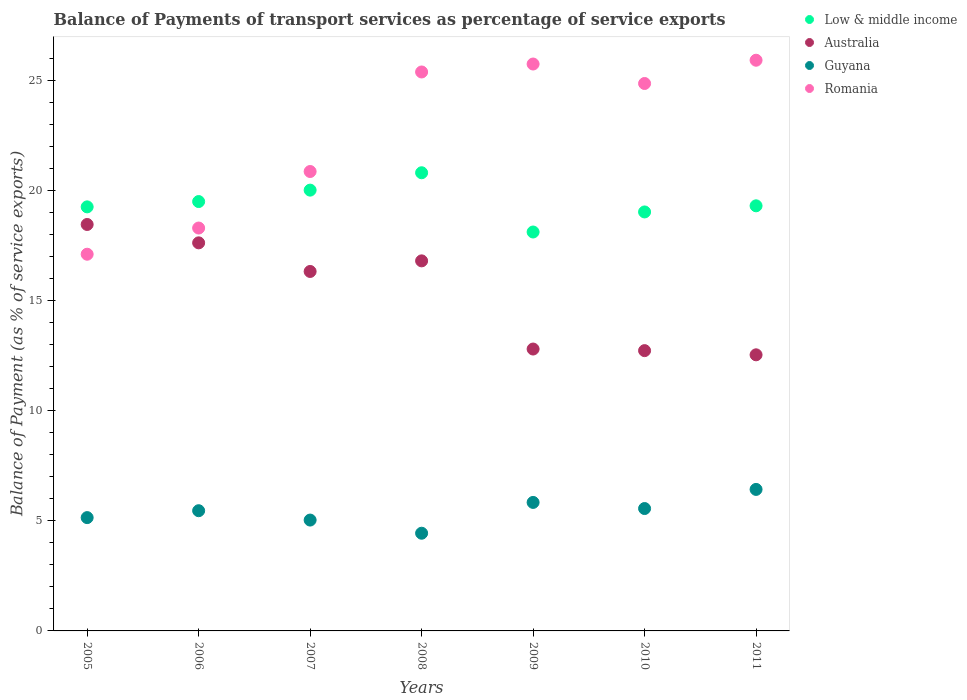How many different coloured dotlines are there?
Your answer should be very brief. 4. What is the balance of payments of transport services in Guyana in 2008?
Your response must be concise. 4.44. Across all years, what is the maximum balance of payments of transport services in Guyana?
Your response must be concise. 6.43. Across all years, what is the minimum balance of payments of transport services in Low & middle income?
Provide a short and direct response. 18.12. In which year was the balance of payments of transport services in Australia maximum?
Your answer should be very brief. 2005. In which year was the balance of payments of transport services in Romania minimum?
Provide a short and direct response. 2005. What is the total balance of payments of transport services in Romania in the graph?
Keep it short and to the point. 158.17. What is the difference between the balance of payments of transport services in Romania in 2010 and that in 2011?
Ensure brevity in your answer.  -1.06. What is the difference between the balance of payments of transport services in Romania in 2006 and the balance of payments of transport services in Low & middle income in 2005?
Provide a succinct answer. -0.96. What is the average balance of payments of transport services in Low & middle income per year?
Give a very brief answer. 19.43. In the year 2008, what is the difference between the balance of payments of transport services in Low & middle income and balance of payments of transport services in Guyana?
Provide a succinct answer. 16.37. What is the ratio of the balance of payments of transport services in Australia in 2005 to that in 2008?
Your answer should be compact. 1.1. Is the balance of payments of transport services in Low & middle income in 2008 less than that in 2011?
Provide a short and direct response. No. What is the difference between the highest and the second highest balance of payments of transport services in Australia?
Offer a very short reply. 0.83. What is the difference between the highest and the lowest balance of payments of transport services in Low & middle income?
Your answer should be very brief. 2.69. Is the sum of the balance of payments of transport services in Low & middle income in 2007 and 2011 greater than the maximum balance of payments of transport services in Romania across all years?
Your answer should be very brief. Yes. Is it the case that in every year, the sum of the balance of payments of transport services in Low & middle income and balance of payments of transport services in Guyana  is greater than the sum of balance of payments of transport services in Australia and balance of payments of transport services in Romania?
Offer a very short reply. Yes. Is it the case that in every year, the sum of the balance of payments of transport services in Australia and balance of payments of transport services in Guyana  is greater than the balance of payments of transport services in Romania?
Give a very brief answer. No. Does the balance of payments of transport services in Low & middle income monotonically increase over the years?
Provide a succinct answer. No. Is the balance of payments of transport services in Australia strictly greater than the balance of payments of transport services in Romania over the years?
Provide a succinct answer. No. How many years are there in the graph?
Provide a short and direct response. 7. What is the difference between two consecutive major ticks on the Y-axis?
Your answer should be compact. 5. Are the values on the major ticks of Y-axis written in scientific E-notation?
Give a very brief answer. No. Does the graph contain any zero values?
Offer a terse response. No. Where does the legend appear in the graph?
Ensure brevity in your answer.  Top right. How many legend labels are there?
Give a very brief answer. 4. How are the legend labels stacked?
Your answer should be compact. Vertical. What is the title of the graph?
Make the answer very short. Balance of Payments of transport services as percentage of service exports. What is the label or title of the Y-axis?
Your response must be concise. Balance of Payment (as % of service exports). What is the Balance of Payment (as % of service exports) in Low & middle income in 2005?
Give a very brief answer. 19.26. What is the Balance of Payment (as % of service exports) in Australia in 2005?
Provide a short and direct response. 18.46. What is the Balance of Payment (as % of service exports) in Guyana in 2005?
Your answer should be very brief. 5.15. What is the Balance of Payment (as % of service exports) of Romania in 2005?
Your response must be concise. 17.11. What is the Balance of Payment (as % of service exports) of Low & middle income in 2006?
Keep it short and to the point. 19.5. What is the Balance of Payment (as % of service exports) of Australia in 2006?
Ensure brevity in your answer.  17.62. What is the Balance of Payment (as % of service exports) in Guyana in 2006?
Offer a very short reply. 5.46. What is the Balance of Payment (as % of service exports) of Romania in 2006?
Give a very brief answer. 18.3. What is the Balance of Payment (as % of service exports) of Low & middle income in 2007?
Offer a very short reply. 20.02. What is the Balance of Payment (as % of service exports) in Australia in 2007?
Your answer should be compact. 16.32. What is the Balance of Payment (as % of service exports) of Guyana in 2007?
Provide a short and direct response. 5.03. What is the Balance of Payment (as % of service exports) in Romania in 2007?
Make the answer very short. 20.86. What is the Balance of Payment (as % of service exports) in Low & middle income in 2008?
Make the answer very short. 20.81. What is the Balance of Payment (as % of service exports) of Australia in 2008?
Your response must be concise. 16.81. What is the Balance of Payment (as % of service exports) in Guyana in 2008?
Provide a succinct answer. 4.44. What is the Balance of Payment (as % of service exports) in Romania in 2008?
Offer a terse response. 25.38. What is the Balance of Payment (as % of service exports) of Low & middle income in 2009?
Make the answer very short. 18.12. What is the Balance of Payment (as % of service exports) of Australia in 2009?
Ensure brevity in your answer.  12.8. What is the Balance of Payment (as % of service exports) of Guyana in 2009?
Provide a succinct answer. 5.84. What is the Balance of Payment (as % of service exports) in Romania in 2009?
Make the answer very short. 25.74. What is the Balance of Payment (as % of service exports) in Low & middle income in 2010?
Your answer should be very brief. 19.03. What is the Balance of Payment (as % of service exports) in Australia in 2010?
Your answer should be very brief. 12.73. What is the Balance of Payment (as % of service exports) in Guyana in 2010?
Offer a very short reply. 5.56. What is the Balance of Payment (as % of service exports) in Romania in 2010?
Keep it short and to the point. 24.86. What is the Balance of Payment (as % of service exports) of Low & middle income in 2011?
Offer a terse response. 19.31. What is the Balance of Payment (as % of service exports) of Australia in 2011?
Make the answer very short. 12.54. What is the Balance of Payment (as % of service exports) of Guyana in 2011?
Offer a terse response. 6.43. What is the Balance of Payment (as % of service exports) of Romania in 2011?
Make the answer very short. 25.92. Across all years, what is the maximum Balance of Payment (as % of service exports) in Low & middle income?
Provide a short and direct response. 20.81. Across all years, what is the maximum Balance of Payment (as % of service exports) in Australia?
Ensure brevity in your answer.  18.46. Across all years, what is the maximum Balance of Payment (as % of service exports) in Guyana?
Ensure brevity in your answer.  6.43. Across all years, what is the maximum Balance of Payment (as % of service exports) in Romania?
Your answer should be compact. 25.92. Across all years, what is the minimum Balance of Payment (as % of service exports) of Low & middle income?
Offer a very short reply. 18.12. Across all years, what is the minimum Balance of Payment (as % of service exports) in Australia?
Provide a short and direct response. 12.54. Across all years, what is the minimum Balance of Payment (as % of service exports) of Guyana?
Your response must be concise. 4.44. Across all years, what is the minimum Balance of Payment (as % of service exports) of Romania?
Offer a very short reply. 17.11. What is the total Balance of Payment (as % of service exports) of Low & middle income in the graph?
Offer a terse response. 136.03. What is the total Balance of Payment (as % of service exports) of Australia in the graph?
Provide a short and direct response. 107.28. What is the total Balance of Payment (as % of service exports) of Guyana in the graph?
Offer a very short reply. 37.9. What is the total Balance of Payment (as % of service exports) in Romania in the graph?
Provide a succinct answer. 158.17. What is the difference between the Balance of Payment (as % of service exports) of Low & middle income in 2005 and that in 2006?
Ensure brevity in your answer.  -0.24. What is the difference between the Balance of Payment (as % of service exports) in Australia in 2005 and that in 2006?
Keep it short and to the point. 0.83. What is the difference between the Balance of Payment (as % of service exports) in Guyana in 2005 and that in 2006?
Your answer should be compact. -0.31. What is the difference between the Balance of Payment (as % of service exports) in Romania in 2005 and that in 2006?
Ensure brevity in your answer.  -1.19. What is the difference between the Balance of Payment (as % of service exports) in Low & middle income in 2005 and that in 2007?
Offer a terse response. -0.76. What is the difference between the Balance of Payment (as % of service exports) of Australia in 2005 and that in 2007?
Offer a terse response. 2.13. What is the difference between the Balance of Payment (as % of service exports) in Guyana in 2005 and that in 2007?
Provide a short and direct response. 0.11. What is the difference between the Balance of Payment (as % of service exports) of Romania in 2005 and that in 2007?
Keep it short and to the point. -3.76. What is the difference between the Balance of Payment (as % of service exports) of Low & middle income in 2005 and that in 2008?
Offer a very short reply. -1.55. What is the difference between the Balance of Payment (as % of service exports) of Australia in 2005 and that in 2008?
Offer a very short reply. 1.65. What is the difference between the Balance of Payment (as % of service exports) of Guyana in 2005 and that in 2008?
Offer a very short reply. 0.71. What is the difference between the Balance of Payment (as % of service exports) in Romania in 2005 and that in 2008?
Provide a succinct answer. -8.28. What is the difference between the Balance of Payment (as % of service exports) of Low & middle income in 2005 and that in 2009?
Your answer should be compact. 1.14. What is the difference between the Balance of Payment (as % of service exports) of Australia in 2005 and that in 2009?
Provide a short and direct response. 5.66. What is the difference between the Balance of Payment (as % of service exports) of Guyana in 2005 and that in 2009?
Ensure brevity in your answer.  -0.69. What is the difference between the Balance of Payment (as % of service exports) in Romania in 2005 and that in 2009?
Offer a very short reply. -8.64. What is the difference between the Balance of Payment (as % of service exports) in Low & middle income in 2005 and that in 2010?
Keep it short and to the point. 0.23. What is the difference between the Balance of Payment (as % of service exports) in Australia in 2005 and that in 2010?
Provide a succinct answer. 5.73. What is the difference between the Balance of Payment (as % of service exports) in Guyana in 2005 and that in 2010?
Offer a terse response. -0.41. What is the difference between the Balance of Payment (as % of service exports) in Romania in 2005 and that in 2010?
Your response must be concise. -7.75. What is the difference between the Balance of Payment (as % of service exports) of Low & middle income in 2005 and that in 2011?
Your response must be concise. -0.05. What is the difference between the Balance of Payment (as % of service exports) of Australia in 2005 and that in 2011?
Provide a short and direct response. 5.92. What is the difference between the Balance of Payment (as % of service exports) of Guyana in 2005 and that in 2011?
Keep it short and to the point. -1.28. What is the difference between the Balance of Payment (as % of service exports) of Romania in 2005 and that in 2011?
Ensure brevity in your answer.  -8.81. What is the difference between the Balance of Payment (as % of service exports) of Low & middle income in 2006 and that in 2007?
Your answer should be compact. -0.52. What is the difference between the Balance of Payment (as % of service exports) in Australia in 2006 and that in 2007?
Provide a short and direct response. 1.3. What is the difference between the Balance of Payment (as % of service exports) in Guyana in 2006 and that in 2007?
Give a very brief answer. 0.42. What is the difference between the Balance of Payment (as % of service exports) in Romania in 2006 and that in 2007?
Make the answer very short. -2.57. What is the difference between the Balance of Payment (as % of service exports) in Low & middle income in 2006 and that in 2008?
Provide a succinct answer. -1.31. What is the difference between the Balance of Payment (as % of service exports) of Australia in 2006 and that in 2008?
Ensure brevity in your answer.  0.82. What is the difference between the Balance of Payment (as % of service exports) in Guyana in 2006 and that in 2008?
Provide a succinct answer. 1.02. What is the difference between the Balance of Payment (as % of service exports) of Romania in 2006 and that in 2008?
Provide a short and direct response. -7.09. What is the difference between the Balance of Payment (as % of service exports) in Low & middle income in 2006 and that in 2009?
Offer a very short reply. 1.38. What is the difference between the Balance of Payment (as % of service exports) of Australia in 2006 and that in 2009?
Keep it short and to the point. 4.82. What is the difference between the Balance of Payment (as % of service exports) of Guyana in 2006 and that in 2009?
Your response must be concise. -0.38. What is the difference between the Balance of Payment (as % of service exports) of Romania in 2006 and that in 2009?
Offer a very short reply. -7.45. What is the difference between the Balance of Payment (as % of service exports) of Low & middle income in 2006 and that in 2010?
Your answer should be compact. 0.47. What is the difference between the Balance of Payment (as % of service exports) of Australia in 2006 and that in 2010?
Make the answer very short. 4.89. What is the difference between the Balance of Payment (as % of service exports) of Guyana in 2006 and that in 2010?
Your answer should be very brief. -0.1. What is the difference between the Balance of Payment (as % of service exports) in Romania in 2006 and that in 2010?
Your answer should be very brief. -6.56. What is the difference between the Balance of Payment (as % of service exports) of Low & middle income in 2006 and that in 2011?
Provide a short and direct response. 0.19. What is the difference between the Balance of Payment (as % of service exports) in Australia in 2006 and that in 2011?
Provide a short and direct response. 5.08. What is the difference between the Balance of Payment (as % of service exports) in Guyana in 2006 and that in 2011?
Make the answer very short. -0.97. What is the difference between the Balance of Payment (as % of service exports) in Romania in 2006 and that in 2011?
Give a very brief answer. -7.62. What is the difference between the Balance of Payment (as % of service exports) in Low & middle income in 2007 and that in 2008?
Ensure brevity in your answer.  -0.79. What is the difference between the Balance of Payment (as % of service exports) in Australia in 2007 and that in 2008?
Your answer should be compact. -0.48. What is the difference between the Balance of Payment (as % of service exports) of Guyana in 2007 and that in 2008?
Give a very brief answer. 0.6. What is the difference between the Balance of Payment (as % of service exports) of Romania in 2007 and that in 2008?
Provide a short and direct response. -4.52. What is the difference between the Balance of Payment (as % of service exports) in Low & middle income in 2007 and that in 2009?
Your response must be concise. 1.9. What is the difference between the Balance of Payment (as % of service exports) of Australia in 2007 and that in 2009?
Your answer should be compact. 3.52. What is the difference between the Balance of Payment (as % of service exports) in Guyana in 2007 and that in 2009?
Provide a succinct answer. -0.8. What is the difference between the Balance of Payment (as % of service exports) in Romania in 2007 and that in 2009?
Provide a succinct answer. -4.88. What is the difference between the Balance of Payment (as % of service exports) in Low & middle income in 2007 and that in 2010?
Your answer should be very brief. 0.99. What is the difference between the Balance of Payment (as % of service exports) of Australia in 2007 and that in 2010?
Offer a terse response. 3.6. What is the difference between the Balance of Payment (as % of service exports) in Guyana in 2007 and that in 2010?
Your answer should be very brief. -0.52. What is the difference between the Balance of Payment (as % of service exports) of Romania in 2007 and that in 2010?
Ensure brevity in your answer.  -4. What is the difference between the Balance of Payment (as % of service exports) of Low & middle income in 2007 and that in 2011?
Your answer should be compact. 0.71. What is the difference between the Balance of Payment (as % of service exports) of Australia in 2007 and that in 2011?
Your response must be concise. 3.79. What is the difference between the Balance of Payment (as % of service exports) in Guyana in 2007 and that in 2011?
Give a very brief answer. -1.39. What is the difference between the Balance of Payment (as % of service exports) in Romania in 2007 and that in 2011?
Your answer should be compact. -5.05. What is the difference between the Balance of Payment (as % of service exports) of Low & middle income in 2008 and that in 2009?
Offer a terse response. 2.69. What is the difference between the Balance of Payment (as % of service exports) in Australia in 2008 and that in 2009?
Keep it short and to the point. 4. What is the difference between the Balance of Payment (as % of service exports) of Guyana in 2008 and that in 2009?
Your response must be concise. -1.4. What is the difference between the Balance of Payment (as % of service exports) in Romania in 2008 and that in 2009?
Your answer should be compact. -0.36. What is the difference between the Balance of Payment (as % of service exports) in Low & middle income in 2008 and that in 2010?
Keep it short and to the point. 1.78. What is the difference between the Balance of Payment (as % of service exports) in Australia in 2008 and that in 2010?
Ensure brevity in your answer.  4.08. What is the difference between the Balance of Payment (as % of service exports) in Guyana in 2008 and that in 2010?
Offer a very short reply. -1.12. What is the difference between the Balance of Payment (as % of service exports) of Romania in 2008 and that in 2010?
Offer a very short reply. 0.52. What is the difference between the Balance of Payment (as % of service exports) in Low & middle income in 2008 and that in 2011?
Provide a short and direct response. 1.5. What is the difference between the Balance of Payment (as % of service exports) in Australia in 2008 and that in 2011?
Provide a short and direct response. 4.27. What is the difference between the Balance of Payment (as % of service exports) in Guyana in 2008 and that in 2011?
Your response must be concise. -1.99. What is the difference between the Balance of Payment (as % of service exports) in Romania in 2008 and that in 2011?
Ensure brevity in your answer.  -0.53. What is the difference between the Balance of Payment (as % of service exports) in Low & middle income in 2009 and that in 2010?
Provide a short and direct response. -0.91. What is the difference between the Balance of Payment (as % of service exports) in Australia in 2009 and that in 2010?
Give a very brief answer. 0.07. What is the difference between the Balance of Payment (as % of service exports) in Guyana in 2009 and that in 2010?
Give a very brief answer. 0.28. What is the difference between the Balance of Payment (as % of service exports) of Romania in 2009 and that in 2010?
Give a very brief answer. 0.88. What is the difference between the Balance of Payment (as % of service exports) in Low & middle income in 2009 and that in 2011?
Provide a short and direct response. -1.19. What is the difference between the Balance of Payment (as % of service exports) in Australia in 2009 and that in 2011?
Ensure brevity in your answer.  0.26. What is the difference between the Balance of Payment (as % of service exports) of Guyana in 2009 and that in 2011?
Make the answer very short. -0.59. What is the difference between the Balance of Payment (as % of service exports) in Romania in 2009 and that in 2011?
Offer a terse response. -0.17. What is the difference between the Balance of Payment (as % of service exports) in Low & middle income in 2010 and that in 2011?
Offer a terse response. -0.28. What is the difference between the Balance of Payment (as % of service exports) in Australia in 2010 and that in 2011?
Give a very brief answer. 0.19. What is the difference between the Balance of Payment (as % of service exports) in Guyana in 2010 and that in 2011?
Your answer should be compact. -0.87. What is the difference between the Balance of Payment (as % of service exports) in Romania in 2010 and that in 2011?
Offer a very short reply. -1.06. What is the difference between the Balance of Payment (as % of service exports) of Low & middle income in 2005 and the Balance of Payment (as % of service exports) of Australia in 2006?
Give a very brief answer. 1.63. What is the difference between the Balance of Payment (as % of service exports) of Low & middle income in 2005 and the Balance of Payment (as % of service exports) of Guyana in 2006?
Make the answer very short. 13.8. What is the difference between the Balance of Payment (as % of service exports) of Low & middle income in 2005 and the Balance of Payment (as % of service exports) of Romania in 2006?
Your answer should be very brief. 0.96. What is the difference between the Balance of Payment (as % of service exports) in Australia in 2005 and the Balance of Payment (as % of service exports) in Guyana in 2006?
Your response must be concise. 13. What is the difference between the Balance of Payment (as % of service exports) of Australia in 2005 and the Balance of Payment (as % of service exports) of Romania in 2006?
Your answer should be compact. 0.16. What is the difference between the Balance of Payment (as % of service exports) of Guyana in 2005 and the Balance of Payment (as % of service exports) of Romania in 2006?
Offer a very short reply. -13.15. What is the difference between the Balance of Payment (as % of service exports) in Low & middle income in 2005 and the Balance of Payment (as % of service exports) in Australia in 2007?
Give a very brief answer. 2.93. What is the difference between the Balance of Payment (as % of service exports) in Low & middle income in 2005 and the Balance of Payment (as % of service exports) in Guyana in 2007?
Offer a very short reply. 14.22. What is the difference between the Balance of Payment (as % of service exports) of Low & middle income in 2005 and the Balance of Payment (as % of service exports) of Romania in 2007?
Make the answer very short. -1.61. What is the difference between the Balance of Payment (as % of service exports) in Australia in 2005 and the Balance of Payment (as % of service exports) in Guyana in 2007?
Keep it short and to the point. 13.42. What is the difference between the Balance of Payment (as % of service exports) of Australia in 2005 and the Balance of Payment (as % of service exports) of Romania in 2007?
Your answer should be compact. -2.41. What is the difference between the Balance of Payment (as % of service exports) of Guyana in 2005 and the Balance of Payment (as % of service exports) of Romania in 2007?
Your response must be concise. -15.72. What is the difference between the Balance of Payment (as % of service exports) in Low & middle income in 2005 and the Balance of Payment (as % of service exports) in Australia in 2008?
Keep it short and to the point. 2.45. What is the difference between the Balance of Payment (as % of service exports) in Low & middle income in 2005 and the Balance of Payment (as % of service exports) in Guyana in 2008?
Provide a short and direct response. 14.82. What is the difference between the Balance of Payment (as % of service exports) of Low & middle income in 2005 and the Balance of Payment (as % of service exports) of Romania in 2008?
Offer a very short reply. -6.13. What is the difference between the Balance of Payment (as % of service exports) in Australia in 2005 and the Balance of Payment (as % of service exports) in Guyana in 2008?
Provide a succinct answer. 14.02. What is the difference between the Balance of Payment (as % of service exports) of Australia in 2005 and the Balance of Payment (as % of service exports) of Romania in 2008?
Provide a succinct answer. -6.93. What is the difference between the Balance of Payment (as % of service exports) in Guyana in 2005 and the Balance of Payment (as % of service exports) in Romania in 2008?
Provide a succinct answer. -20.24. What is the difference between the Balance of Payment (as % of service exports) in Low & middle income in 2005 and the Balance of Payment (as % of service exports) in Australia in 2009?
Provide a succinct answer. 6.46. What is the difference between the Balance of Payment (as % of service exports) in Low & middle income in 2005 and the Balance of Payment (as % of service exports) in Guyana in 2009?
Provide a succinct answer. 13.42. What is the difference between the Balance of Payment (as % of service exports) of Low & middle income in 2005 and the Balance of Payment (as % of service exports) of Romania in 2009?
Make the answer very short. -6.49. What is the difference between the Balance of Payment (as % of service exports) in Australia in 2005 and the Balance of Payment (as % of service exports) in Guyana in 2009?
Your response must be concise. 12.62. What is the difference between the Balance of Payment (as % of service exports) of Australia in 2005 and the Balance of Payment (as % of service exports) of Romania in 2009?
Ensure brevity in your answer.  -7.29. What is the difference between the Balance of Payment (as % of service exports) of Guyana in 2005 and the Balance of Payment (as % of service exports) of Romania in 2009?
Make the answer very short. -20.6. What is the difference between the Balance of Payment (as % of service exports) in Low & middle income in 2005 and the Balance of Payment (as % of service exports) in Australia in 2010?
Ensure brevity in your answer.  6.53. What is the difference between the Balance of Payment (as % of service exports) in Low & middle income in 2005 and the Balance of Payment (as % of service exports) in Guyana in 2010?
Keep it short and to the point. 13.7. What is the difference between the Balance of Payment (as % of service exports) in Low & middle income in 2005 and the Balance of Payment (as % of service exports) in Romania in 2010?
Keep it short and to the point. -5.6. What is the difference between the Balance of Payment (as % of service exports) of Australia in 2005 and the Balance of Payment (as % of service exports) of Guyana in 2010?
Keep it short and to the point. 12.9. What is the difference between the Balance of Payment (as % of service exports) in Australia in 2005 and the Balance of Payment (as % of service exports) in Romania in 2010?
Give a very brief answer. -6.4. What is the difference between the Balance of Payment (as % of service exports) of Guyana in 2005 and the Balance of Payment (as % of service exports) of Romania in 2010?
Offer a very short reply. -19.71. What is the difference between the Balance of Payment (as % of service exports) in Low & middle income in 2005 and the Balance of Payment (as % of service exports) in Australia in 2011?
Your response must be concise. 6.72. What is the difference between the Balance of Payment (as % of service exports) in Low & middle income in 2005 and the Balance of Payment (as % of service exports) in Guyana in 2011?
Provide a short and direct response. 12.83. What is the difference between the Balance of Payment (as % of service exports) of Low & middle income in 2005 and the Balance of Payment (as % of service exports) of Romania in 2011?
Your response must be concise. -6.66. What is the difference between the Balance of Payment (as % of service exports) in Australia in 2005 and the Balance of Payment (as % of service exports) in Guyana in 2011?
Provide a succinct answer. 12.03. What is the difference between the Balance of Payment (as % of service exports) in Australia in 2005 and the Balance of Payment (as % of service exports) in Romania in 2011?
Provide a short and direct response. -7.46. What is the difference between the Balance of Payment (as % of service exports) in Guyana in 2005 and the Balance of Payment (as % of service exports) in Romania in 2011?
Ensure brevity in your answer.  -20.77. What is the difference between the Balance of Payment (as % of service exports) in Low & middle income in 2006 and the Balance of Payment (as % of service exports) in Australia in 2007?
Your answer should be compact. 3.17. What is the difference between the Balance of Payment (as % of service exports) in Low & middle income in 2006 and the Balance of Payment (as % of service exports) in Guyana in 2007?
Make the answer very short. 14.46. What is the difference between the Balance of Payment (as % of service exports) in Low & middle income in 2006 and the Balance of Payment (as % of service exports) in Romania in 2007?
Provide a succinct answer. -1.36. What is the difference between the Balance of Payment (as % of service exports) in Australia in 2006 and the Balance of Payment (as % of service exports) in Guyana in 2007?
Offer a very short reply. 12.59. What is the difference between the Balance of Payment (as % of service exports) of Australia in 2006 and the Balance of Payment (as % of service exports) of Romania in 2007?
Keep it short and to the point. -3.24. What is the difference between the Balance of Payment (as % of service exports) of Guyana in 2006 and the Balance of Payment (as % of service exports) of Romania in 2007?
Your response must be concise. -15.4. What is the difference between the Balance of Payment (as % of service exports) of Low & middle income in 2006 and the Balance of Payment (as % of service exports) of Australia in 2008?
Your answer should be compact. 2.69. What is the difference between the Balance of Payment (as % of service exports) in Low & middle income in 2006 and the Balance of Payment (as % of service exports) in Guyana in 2008?
Your response must be concise. 15.06. What is the difference between the Balance of Payment (as % of service exports) of Low & middle income in 2006 and the Balance of Payment (as % of service exports) of Romania in 2008?
Your answer should be compact. -5.88. What is the difference between the Balance of Payment (as % of service exports) in Australia in 2006 and the Balance of Payment (as % of service exports) in Guyana in 2008?
Offer a very short reply. 13.19. What is the difference between the Balance of Payment (as % of service exports) of Australia in 2006 and the Balance of Payment (as % of service exports) of Romania in 2008?
Offer a terse response. -7.76. What is the difference between the Balance of Payment (as % of service exports) in Guyana in 2006 and the Balance of Payment (as % of service exports) in Romania in 2008?
Your answer should be very brief. -19.92. What is the difference between the Balance of Payment (as % of service exports) of Low & middle income in 2006 and the Balance of Payment (as % of service exports) of Australia in 2009?
Your answer should be very brief. 6.7. What is the difference between the Balance of Payment (as % of service exports) in Low & middle income in 2006 and the Balance of Payment (as % of service exports) in Guyana in 2009?
Offer a terse response. 13.66. What is the difference between the Balance of Payment (as % of service exports) in Low & middle income in 2006 and the Balance of Payment (as % of service exports) in Romania in 2009?
Keep it short and to the point. -6.25. What is the difference between the Balance of Payment (as % of service exports) of Australia in 2006 and the Balance of Payment (as % of service exports) of Guyana in 2009?
Provide a succinct answer. 11.79. What is the difference between the Balance of Payment (as % of service exports) of Australia in 2006 and the Balance of Payment (as % of service exports) of Romania in 2009?
Offer a very short reply. -8.12. What is the difference between the Balance of Payment (as % of service exports) in Guyana in 2006 and the Balance of Payment (as % of service exports) in Romania in 2009?
Offer a terse response. -20.29. What is the difference between the Balance of Payment (as % of service exports) in Low & middle income in 2006 and the Balance of Payment (as % of service exports) in Australia in 2010?
Offer a very short reply. 6.77. What is the difference between the Balance of Payment (as % of service exports) of Low & middle income in 2006 and the Balance of Payment (as % of service exports) of Guyana in 2010?
Keep it short and to the point. 13.94. What is the difference between the Balance of Payment (as % of service exports) in Low & middle income in 2006 and the Balance of Payment (as % of service exports) in Romania in 2010?
Provide a succinct answer. -5.36. What is the difference between the Balance of Payment (as % of service exports) of Australia in 2006 and the Balance of Payment (as % of service exports) of Guyana in 2010?
Give a very brief answer. 12.07. What is the difference between the Balance of Payment (as % of service exports) in Australia in 2006 and the Balance of Payment (as % of service exports) in Romania in 2010?
Offer a terse response. -7.24. What is the difference between the Balance of Payment (as % of service exports) in Guyana in 2006 and the Balance of Payment (as % of service exports) in Romania in 2010?
Ensure brevity in your answer.  -19.4. What is the difference between the Balance of Payment (as % of service exports) in Low & middle income in 2006 and the Balance of Payment (as % of service exports) in Australia in 2011?
Your answer should be very brief. 6.96. What is the difference between the Balance of Payment (as % of service exports) in Low & middle income in 2006 and the Balance of Payment (as % of service exports) in Guyana in 2011?
Keep it short and to the point. 13.07. What is the difference between the Balance of Payment (as % of service exports) of Low & middle income in 2006 and the Balance of Payment (as % of service exports) of Romania in 2011?
Your answer should be compact. -6.42. What is the difference between the Balance of Payment (as % of service exports) in Australia in 2006 and the Balance of Payment (as % of service exports) in Guyana in 2011?
Your answer should be compact. 11.2. What is the difference between the Balance of Payment (as % of service exports) of Australia in 2006 and the Balance of Payment (as % of service exports) of Romania in 2011?
Your answer should be very brief. -8.29. What is the difference between the Balance of Payment (as % of service exports) in Guyana in 2006 and the Balance of Payment (as % of service exports) in Romania in 2011?
Make the answer very short. -20.46. What is the difference between the Balance of Payment (as % of service exports) of Low & middle income in 2007 and the Balance of Payment (as % of service exports) of Australia in 2008?
Give a very brief answer. 3.21. What is the difference between the Balance of Payment (as % of service exports) of Low & middle income in 2007 and the Balance of Payment (as % of service exports) of Guyana in 2008?
Offer a very short reply. 15.58. What is the difference between the Balance of Payment (as % of service exports) of Low & middle income in 2007 and the Balance of Payment (as % of service exports) of Romania in 2008?
Give a very brief answer. -5.37. What is the difference between the Balance of Payment (as % of service exports) of Australia in 2007 and the Balance of Payment (as % of service exports) of Guyana in 2008?
Your response must be concise. 11.89. What is the difference between the Balance of Payment (as % of service exports) in Australia in 2007 and the Balance of Payment (as % of service exports) in Romania in 2008?
Ensure brevity in your answer.  -9.06. What is the difference between the Balance of Payment (as % of service exports) of Guyana in 2007 and the Balance of Payment (as % of service exports) of Romania in 2008?
Give a very brief answer. -20.35. What is the difference between the Balance of Payment (as % of service exports) in Low & middle income in 2007 and the Balance of Payment (as % of service exports) in Australia in 2009?
Offer a very short reply. 7.22. What is the difference between the Balance of Payment (as % of service exports) of Low & middle income in 2007 and the Balance of Payment (as % of service exports) of Guyana in 2009?
Your answer should be very brief. 14.18. What is the difference between the Balance of Payment (as % of service exports) in Low & middle income in 2007 and the Balance of Payment (as % of service exports) in Romania in 2009?
Keep it short and to the point. -5.73. What is the difference between the Balance of Payment (as % of service exports) of Australia in 2007 and the Balance of Payment (as % of service exports) of Guyana in 2009?
Keep it short and to the point. 10.49. What is the difference between the Balance of Payment (as % of service exports) of Australia in 2007 and the Balance of Payment (as % of service exports) of Romania in 2009?
Ensure brevity in your answer.  -9.42. What is the difference between the Balance of Payment (as % of service exports) in Guyana in 2007 and the Balance of Payment (as % of service exports) in Romania in 2009?
Your answer should be compact. -20.71. What is the difference between the Balance of Payment (as % of service exports) in Low & middle income in 2007 and the Balance of Payment (as % of service exports) in Australia in 2010?
Your answer should be very brief. 7.29. What is the difference between the Balance of Payment (as % of service exports) in Low & middle income in 2007 and the Balance of Payment (as % of service exports) in Guyana in 2010?
Your answer should be compact. 14.46. What is the difference between the Balance of Payment (as % of service exports) of Low & middle income in 2007 and the Balance of Payment (as % of service exports) of Romania in 2010?
Ensure brevity in your answer.  -4.84. What is the difference between the Balance of Payment (as % of service exports) in Australia in 2007 and the Balance of Payment (as % of service exports) in Guyana in 2010?
Your answer should be very brief. 10.77. What is the difference between the Balance of Payment (as % of service exports) of Australia in 2007 and the Balance of Payment (as % of service exports) of Romania in 2010?
Provide a succinct answer. -8.54. What is the difference between the Balance of Payment (as % of service exports) of Guyana in 2007 and the Balance of Payment (as % of service exports) of Romania in 2010?
Your answer should be very brief. -19.83. What is the difference between the Balance of Payment (as % of service exports) in Low & middle income in 2007 and the Balance of Payment (as % of service exports) in Australia in 2011?
Provide a short and direct response. 7.48. What is the difference between the Balance of Payment (as % of service exports) in Low & middle income in 2007 and the Balance of Payment (as % of service exports) in Guyana in 2011?
Give a very brief answer. 13.59. What is the difference between the Balance of Payment (as % of service exports) in Low & middle income in 2007 and the Balance of Payment (as % of service exports) in Romania in 2011?
Keep it short and to the point. -5.9. What is the difference between the Balance of Payment (as % of service exports) of Australia in 2007 and the Balance of Payment (as % of service exports) of Guyana in 2011?
Your response must be concise. 9.9. What is the difference between the Balance of Payment (as % of service exports) in Australia in 2007 and the Balance of Payment (as % of service exports) in Romania in 2011?
Provide a short and direct response. -9.59. What is the difference between the Balance of Payment (as % of service exports) of Guyana in 2007 and the Balance of Payment (as % of service exports) of Romania in 2011?
Ensure brevity in your answer.  -20.88. What is the difference between the Balance of Payment (as % of service exports) in Low & middle income in 2008 and the Balance of Payment (as % of service exports) in Australia in 2009?
Offer a very short reply. 8.01. What is the difference between the Balance of Payment (as % of service exports) in Low & middle income in 2008 and the Balance of Payment (as % of service exports) in Guyana in 2009?
Your answer should be very brief. 14.97. What is the difference between the Balance of Payment (as % of service exports) in Low & middle income in 2008 and the Balance of Payment (as % of service exports) in Romania in 2009?
Your response must be concise. -4.94. What is the difference between the Balance of Payment (as % of service exports) of Australia in 2008 and the Balance of Payment (as % of service exports) of Guyana in 2009?
Give a very brief answer. 10.97. What is the difference between the Balance of Payment (as % of service exports) in Australia in 2008 and the Balance of Payment (as % of service exports) in Romania in 2009?
Provide a succinct answer. -8.94. What is the difference between the Balance of Payment (as % of service exports) in Guyana in 2008 and the Balance of Payment (as % of service exports) in Romania in 2009?
Make the answer very short. -21.31. What is the difference between the Balance of Payment (as % of service exports) in Low & middle income in 2008 and the Balance of Payment (as % of service exports) in Australia in 2010?
Keep it short and to the point. 8.08. What is the difference between the Balance of Payment (as % of service exports) of Low & middle income in 2008 and the Balance of Payment (as % of service exports) of Guyana in 2010?
Give a very brief answer. 15.25. What is the difference between the Balance of Payment (as % of service exports) of Low & middle income in 2008 and the Balance of Payment (as % of service exports) of Romania in 2010?
Give a very brief answer. -4.05. What is the difference between the Balance of Payment (as % of service exports) of Australia in 2008 and the Balance of Payment (as % of service exports) of Guyana in 2010?
Provide a short and direct response. 11.25. What is the difference between the Balance of Payment (as % of service exports) in Australia in 2008 and the Balance of Payment (as % of service exports) in Romania in 2010?
Give a very brief answer. -8.05. What is the difference between the Balance of Payment (as % of service exports) of Guyana in 2008 and the Balance of Payment (as % of service exports) of Romania in 2010?
Provide a succinct answer. -20.42. What is the difference between the Balance of Payment (as % of service exports) in Low & middle income in 2008 and the Balance of Payment (as % of service exports) in Australia in 2011?
Give a very brief answer. 8.27. What is the difference between the Balance of Payment (as % of service exports) of Low & middle income in 2008 and the Balance of Payment (as % of service exports) of Guyana in 2011?
Keep it short and to the point. 14.38. What is the difference between the Balance of Payment (as % of service exports) of Low & middle income in 2008 and the Balance of Payment (as % of service exports) of Romania in 2011?
Your answer should be very brief. -5.11. What is the difference between the Balance of Payment (as % of service exports) in Australia in 2008 and the Balance of Payment (as % of service exports) in Guyana in 2011?
Offer a terse response. 10.38. What is the difference between the Balance of Payment (as % of service exports) of Australia in 2008 and the Balance of Payment (as % of service exports) of Romania in 2011?
Your answer should be very brief. -9.11. What is the difference between the Balance of Payment (as % of service exports) of Guyana in 2008 and the Balance of Payment (as % of service exports) of Romania in 2011?
Your answer should be very brief. -21.48. What is the difference between the Balance of Payment (as % of service exports) of Low & middle income in 2009 and the Balance of Payment (as % of service exports) of Australia in 2010?
Keep it short and to the point. 5.39. What is the difference between the Balance of Payment (as % of service exports) of Low & middle income in 2009 and the Balance of Payment (as % of service exports) of Guyana in 2010?
Ensure brevity in your answer.  12.56. What is the difference between the Balance of Payment (as % of service exports) of Low & middle income in 2009 and the Balance of Payment (as % of service exports) of Romania in 2010?
Keep it short and to the point. -6.74. What is the difference between the Balance of Payment (as % of service exports) in Australia in 2009 and the Balance of Payment (as % of service exports) in Guyana in 2010?
Make the answer very short. 7.24. What is the difference between the Balance of Payment (as % of service exports) in Australia in 2009 and the Balance of Payment (as % of service exports) in Romania in 2010?
Provide a succinct answer. -12.06. What is the difference between the Balance of Payment (as % of service exports) in Guyana in 2009 and the Balance of Payment (as % of service exports) in Romania in 2010?
Offer a very short reply. -19.02. What is the difference between the Balance of Payment (as % of service exports) in Low & middle income in 2009 and the Balance of Payment (as % of service exports) in Australia in 2011?
Keep it short and to the point. 5.58. What is the difference between the Balance of Payment (as % of service exports) of Low & middle income in 2009 and the Balance of Payment (as % of service exports) of Guyana in 2011?
Keep it short and to the point. 11.69. What is the difference between the Balance of Payment (as % of service exports) of Low & middle income in 2009 and the Balance of Payment (as % of service exports) of Romania in 2011?
Provide a short and direct response. -7.8. What is the difference between the Balance of Payment (as % of service exports) of Australia in 2009 and the Balance of Payment (as % of service exports) of Guyana in 2011?
Give a very brief answer. 6.37. What is the difference between the Balance of Payment (as % of service exports) of Australia in 2009 and the Balance of Payment (as % of service exports) of Romania in 2011?
Offer a very short reply. -13.12. What is the difference between the Balance of Payment (as % of service exports) in Guyana in 2009 and the Balance of Payment (as % of service exports) in Romania in 2011?
Offer a terse response. -20.08. What is the difference between the Balance of Payment (as % of service exports) in Low & middle income in 2010 and the Balance of Payment (as % of service exports) in Australia in 2011?
Provide a short and direct response. 6.49. What is the difference between the Balance of Payment (as % of service exports) in Low & middle income in 2010 and the Balance of Payment (as % of service exports) in Guyana in 2011?
Provide a short and direct response. 12.6. What is the difference between the Balance of Payment (as % of service exports) of Low & middle income in 2010 and the Balance of Payment (as % of service exports) of Romania in 2011?
Keep it short and to the point. -6.89. What is the difference between the Balance of Payment (as % of service exports) of Australia in 2010 and the Balance of Payment (as % of service exports) of Guyana in 2011?
Your answer should be compact. 6.3. What is the difference between the Balance of Payment (as % of service exports) in Australia in 2010 and the Balance of Payment (as % of service exports) in Romania in 2011?
Offer a terse response. -13.19. What is the difference between the Balance of Payment (as % of service exports) of Guyana in 2010 and the Balance of Payment (as % of service exports) of Romania in 2011?
Offer a very short reply. -20.36. What is the average Balance of Payment (as % of service exports) of Low & middle income per year?
Your response must be concise. 19.43. What is the average Balance of Payment (as % of service exports) of Australia per year?
Your answer should be very brief. 15.33. What is the average Balance of Payment (as % of service exports) in Guyana per year?
Your answer should be compact. 5.41. What is the average Balance of Payment (as % of service exports) of Romania per year?
Keep it short and to the point. 22.6. In the year 2005, what is the difference between the Balance of Payment (as % of service exports) of Low & middle income and Balance of Payment (as % of service exports) of Australia?
Give a very brief answer. 0.8. In the year 2005, what is the difference between the Balance of Payment (as % of service exports) of Low & middle income and Balance of Payment (as % of service exports) of Guyana?
Give a very brief answer. 14.11. In the year 2005, what is the difference between the Balance of Payment (as % of service exports) in Low & middle income and Balance of Payment (as % of service exports) in Romania?
Make the answer very short. 2.15. In the year 2005, what is the difference between the Balance of Payment (as % of service exports) in Australia and Balance of Payment (as % of service exports) in Guyana?
Make the answer very short. 13.31. In the year 2005, what is the difference between the Balance of Payment (as % of service exports) of Australia and Balance of Payment (as % of service exports) of Romania?
Keep it short and to the point. 1.35. In the year 2005, what is the difference between the Balance of Payment (as % of service exports) in Guyana and Balance of Payment (as % of service exports) in Romania?
Provide a succinct answer. -11.96. In the year 2006, what is the difference between the Balance of Payment (as % of service exports) of Low & middle income and Balance of Payment (as % of service exports) of Australia?
Provide a short and direct response. 1.88. In the year 2006, what is the difference between the Balance of Payment (as % of service exports) of Low & middle income and Balance of Payment (as % of service exports) of Guyana?
Ensure brevity in your answer.  14.04. In the year 2006, what is the difference between the Balance of Payment (as % of service exports) of Low & middle income and Balance of Payment (as % of service exports) of Romania?
Your answer should be compact. 1.2. In the year 2006, what is the difference between the Balance of Payment (as % of service exports) of Australia and Balance of Payment (as % of service exports) of Guyana?
Give a very brief answer. 12.16. In the year 2006, what is the difference between the Balance of Payment (as % of service exports) of Australia and Balance of Payment (as % of service exports) of Romania?
Your answer should be compact. -0.67. In the year 2006, what is the difference between the Balance of Payment (as % of service exports) in Guyana and Balance of Payment (as % of service exports) in Romania?
Offer a very short reply. -12.84. In the year 2007, what is the difference between the Balance of Payment (as % of service exports) of Low & middle income and Balance of Payment (as % of service exports) of Australia?
Your response must be concise. 3.69. In the year 2007, what is the difference between the Balance of Payment (as % of service exports) in Low & middle income and Balance of Payment (as % of service exports) in Guyana?
Your answer should be very brief. 14.98. In the year 2007, what is the difference between the Balance of Payment (as % of service exports) in Low & middle income and Balance of Payment (as % of service exports) in Romania?
Your answer should be compact. -0.85. In the year 2007, what is the difference between the Balance of Payment (as % of service exports) in Australia and Balance of Payment (as % of service exports) in Guyana?
Your response must be concise. 11.29. In the year 2007, what is the difference between the Balance of Payment (as % of service exports) of Australia and Balance of Payment (as % of service exports) of Romania?
Make the answer very short. -4.54. In the year 2007, what is the difference between the Balance of Payment (as % of service exports) of Guyana and Balance of Payment (as % of service exports) of Romania?
Offer a terse response. -15.83. In the year 2008, what is the difference between the Balance of Payment (as % of service exports) of Low & middle income and Balance of Payment (as % of service exports) of Australia?
Your response must be concise. 4. In the year 2008, what is the difference between the Balance of Payment (as % of service exports) of Low & middle income and Balance of Payment (as % of service exports) of Guyana?
Provide a succinct answer. 16.37. In the year 2008, what is the difference between the Balance of Payment (as % of service exports) of Low & middle income and Balance of Payment (as % of service exports) of Romania?
Offer a very short reply. -4.58. In the year 2008, what is the difference between the Balance of Payment (as % of service exports) in Australia and Balance of Payment (as % of service exports) in Guyana?
Offer a very short reply. 12.37. In the year 2008, what is the difference between the Balance of Payment (as % of service exports) in Australia and Balance of Payment (as % of service exports) in Romania?
Ensure brevity in your answer.  -8.58. In the year 2008, what is the difference between the Balance of Payment (as % of service exports) of Guyana and Balance of Payment (as % of service exports) of Romania?
Ensure brevity in your answer.  -20.95. In the year 2009, what is the difference between the Balance of Payment (as % of service exports) of Low & middle income and Balance of Payment (as % of service exports) of Australia?
Keep it short and to the point. 5.31. In the year 2009, what is the difference between the Balance of Payment (as % of service exports) of Low & middle income and Balance of Payment (as % of service exports) of Guyana?
Provide a short and direct response. 12.28. In the year 2009, what is the difference between the Balance of Payment (as % of service exports) of Low & middle income and Balance of Payment (as % of service exports) of Romania?
Make the answer very short. -7.63. In the year 2009, what is the difference between the Balance of Payment (as % of service exports) of Australia and Balance of Payment (as % of service exports) of Guyana?
Keep it short and to the point. 6.97. In the year 2009, what is the difference between the Balance of Payment (as % of service exports) of Australia and Balance of Payment (as % of service exports) of Romania?
Your answer should be compact. -12.94. In the year 2009, what is the difference between the Balance of Payment (as % of service exports) in Guyana and Balance of Payment (as % of service exports) in Romania?
Your response must be concise. -19.91. In the year 2010, what is the difference between the Balance of Payment (as % of service exports) of Low & middle income and Balance of Payment (as % of service exports) of Australia?
Provide a succinct answer. 6.3. In the year 2010, what is the difference between the Balance of Payment (as % of service exports) of Low & middle income and Balance of Payment (as % of service exports) of Guyana?
Your response must be concise. 13.47. In the year 2010, what is the difference between the Balance of Payment (as % of service exports) of Low & middle income and Balance of Payment (as % of service exports) of Romania?
Offer a very short reply. -5.83. In the year 2010, what is the difference between the Balance of Payment (as % of service exports) of Australia and Balance of Payment (as % of service exports) of Guyana?
Your response must be concise. 7.17. In the year 2010, what is the difference between the Balance of Payment (as % of service exports) in Australia and Balance of Payment (as % of service exports) in Romania?
Provide a succinct answer. -12.13. In the year 2010, what is the difference between the Balance of Payment (as % of service exports) of Guyana and Balance of Payment (as % of service exports) of Romania?
Provide a succinct answer. -19.3. In the year 2011, what is the difference between the Balance of Payment (as % of service exports) in Low & middle income and Balance of Payment (as % of service exports) in Australia?
Keep it short and to the point. 6.77. In the year 2011, what is the difference between the Balance of Payment (as % of service exports) in Low & middle income and Balance of Payment (as % of service exports) in Guyana?
Provide a short and direct response. 12.88. In the year 2011, what is the difference between the Balance of Payment (as % of service exports) in Low & middle income and Balance of Payment (as % of service exports) in Romania?
Keep it short and to the point. -6.61. In the year 2011, what is the difference between the Balance of Payment (as % of service exports) of Australia and Balance of Payment (as % of service exports) of Guyana?
Provide a succinct answer. 6.11. In the year 2011, what is the difference between the Balance of Payment (as % of service exports) in Australia and Balance of Payment (as % of service exports) in Romania?
Ensure brevity in your answer.  -13.38. In the year 2011, what is the difference between the Balance of Payment (as % of service exports) of Guyana and Balance of Payment (as % of service exports) of Romania?
Offer a very short reply. -19.49. What is the ratio of the Balance of Payment (as % of service exports) in Low & middle income in 2005 to that in 2006?
Your response must be concise. 0.99. What is the ratio of the Balance of Payment (as % of service exports) in Australia in 2005 to that in 2006?
Your response must be concise. 1.05. What is the ratio of the Balance of Payment (as % of service exports) in Guyana in 2005 to that in 2006?
Make the answer very short. 0.94. What is the ratio of the Balance of Payment (as % of service exports) of Romania in 2005 to that in 2006?
Make the answer very short. 0.94. What is the ratio of the Balance of Payment (as % of service exports) in Low & middle income in 2005 to that in 2007?
Your response must be concise. 0.96. What is the ratio of the Balance of Payment (as % of service exports) in Australia in 2005 to that in 2007?
Your response must be concise. 1.13. What is the ratio of the Balance of Payment (as % of service exports) in Guyana in 2005 to that in 2007?
Offer a terse response. 1.02. What is the ratio of the Balance of Payment (as % of service exports) in Romania in 2005 to that in 2007?
Keep it short and to the point. 0.82. What is the ratio of the Balance of Payment (as % of service exports) of Low & middle income in 2005 to that in 2008?
Your answer should be very brief. 0.93. What is the ratio of the Balance of Payment (as % of service exports) of Australia in 2005 to that in 2008?
Ensure brevity in your answer.  1.1. What is the ratio of the Balance of Payment (as % of service exports) of Guyana in 2005 to that in 2008?
Make the answer very short. 1.16. What is the ratio of the Balance of Payment (as % of service exports) of Romania in 2005 to that in 2008?
Offer a very short reply. 0.67. What is the ratio of the Balance of Payment (as % of service exports) in Low & middle income in 2005 to that in 2009?
Offer a terse response. 1.06. What is the ratio of the Balance of Payment (as % of service exports) of Australia in 2005 to that in 2009?
Offer a terse response. 1.44. What is the ratio of the Balance of Payment (as % of service exports) of Guyana in 2005 to that in 2009?
Offer a terse response. 0.88. What is the ratio of the Balance of Payment (as % of service exports) in Romania in 2005 to that in 2009?
Offer a terse response. 0.66. What is the ratio of the Balance of Payment (as % of service exports) of Low & middle income in 2005 to that in 2010?
Make the answer very short. 1.01. What is the ratio of the Balance of Payment (as % of service exports) in Australia in 2005 to that in 2010?
Give a very brief answer. 1.45. What is the ratio of the Balance of Payment (as % of service exports) in Guyana in 2005 to that in 2010?
Keep it short and to the point. 0.93. What is the ratio of the Balance of Payment (as % of service exports) in Romania in 2005 to that in 2010?
Offer a very short reply. 0.69. What is the ratio of the Balance of Payment (as % of service exports) of Australia in 2005 to that in 2011?
Make the answer very short. 1.47. What is the ratio of the Balance of Payment (as % of service exports) in Guyana in 2005 to that in 2011?
Offer a very short reply. 0.8. What is the ratio of the Balance of Payment (as % of service exports) of Romania in 2005 to that in 2011?
Make the answer very short. 0.66. What is the ratio of the Balance of Payment (as % of service exports) of Low & middle income in 2006 to that in 2007?
Your response must be concise. 0.97. What is the ratio of the Balance of Payment (as % of service exports) in Australia in 2006 to that in 2007?
Make the answer very short. 1.08. What is the ratio of the Balance of Payment (as % of service exports) in Guyana in 2006 to that in 2007?
Offer a terse response. 1.08. What is the ratio of the Balance of Payment (as % of service exports) of Romania in 2006 to that in 2007?
Keep it short and to the point. 0.88. What is the ratio of the Balance of Payment (as % of service exports) of Low & middle income in 2006 to that in 2008?
Provide a short and direct response. 0.94. What is the ratio of the Balance of Payment (as % of service exports) of Australia in 2006 to that in 2008?
Offer a terse response. 1.05. What is the ratio of the Balance of Payment (as % of service exports) of Guyana in 2006 to that in 2008?
Provide a succinct answer. 1.23. What is the ratio of the Balance of Payment (as % of service exports) in Romania in 2006 to that in 2008?
Offer a very short reply. 0.72. What is the ratio of the Balance of Payment (as % of service exports) of Low & middle income in 2006 to that in 2009?
Offer a terse response. 1.08. What is the ratio of the Balance of Payment (as % of service exports) of Australia in 2006 to that in 2009?
Ensure brevity in your answer.  1.38. What is the ratio of the Balance of Payment (as % of service exports) of Guyana in 2006 to that in 2009?
Offer a terse response. 0.94. What is the ratio of the Balance of Payment (as % of service exports) in Romania in 2006 to that in 2009?
Your response must be concise. 0.71. What is the ratio of the Balance of Payment (as % of service exports) in Low & middle income in 2006 to that in 2010?
Offer a terse response. 1.02. What is the ratio of the Balance of Payment (as % of service exports) in Australia in 2006 to that in 2010?
Offer a terse response. 1.38. What is the ratio of the Balance of Payment (as % of service exports) of Guyana in 2006 to that in 2010?
Offer a very short reply. 0.98. What is the ratio of the Balance of Payment (as % of service exports) of Romania in 2006 to that in 2010?
Keep it short and to the point. 0.74. What is the ratio of the Balance of Payment (as % of service exports) of Low & middle income in 2006 to that in 2011?
Your answer should be compact. 1.01. What is the ratio of the Balance of Payment (as % of service exports) of Australia in 2006 to that in 2011?
Ensure brevity in your answer.  1.41. What is the ratio of the Balance of Payment (as % of service exports) of Guyana in 2006 to that in 2011?
Your answer should be very brief. 0.85. What is the ratio of the Balance of Payment (as % of service exports) of Romania in 2006 to that in 2011?
Make the answer very short. 0.71. What is the ratio of the Balance of Payment (as % of service exports) in Low & middle income in 2007 to that in 2008?
Your answer should be compact. 0.96. What is the ratio of the Balance of Payment (as % of service exports) in Australia in 2007 to that in 2008?
Offer a very short reply. 0.97. What is the ratio of the Balance of Payment (as % of service exports) of Guyana in 2007 to that in 2008?
Give a very brief answer. 1.13. What is the ratio of the Balance of Payment (as % of service exports) of Romania in 2007 to that in 2008?
Provide a succinct answer. 0.82. What is the ratio of the Balance of Payment (as % of service exports) of Low & middle income in 2007 to that in 2009?
Provide a short and direct response. 1.1. What is the ratio of the Balance of Payment (as % of service exports) of Australia in 2007 to that in 2009?
Keep it short and to the point. 1.28. What is the ratio of the Balance of Payment (as % of service exports) of Guyana in 2007 to that in 2009?
Your answer should be very brief. 0.86. What is the ratio of the Balance of Payment (as % of service exports) of Romania in 2007 to that in 2009?
Your response must be concise. 0.81. What is the ratio of the Balance of Payment (as % of service exports) in Low & middle income in 2007 to that in 2010?
Offer a very short reply. 1.05. What is the ratio of the Balance of Payment (as % of service exports) of Australia in 2007 to that in 2010?
Your answer should be very brief. 1.28. What is the ratio of the Balance of Payment (as % of service exports) in Guyana in 2007 to that in 2010?
Offer a terse response. 0.91. What is the ratio of the Balance of Payment (as % of service exports) of Romania in 2007 to that in 2010?
Make the answer very short. 0.84. What is the ratio of the Balance of Payment (as % of service exports) in Low & middle income in 2007 to that in 2011?
Keep it short and to the point. 1.04. What is the ratio of the Balance of Payment (as % of service exports) in Australia in 2007 to that in 2011?
Ensure brevity in your answer.  1.3. What is the ratio of the Balance of Payment (as % of service exports) in Guyana in 2007 to that in 2011?
Give a very brief answer. 0.78. What is the ratio of the Balance of Payment (as % of service exports) in Romania in 2007 to that in 2011?
Your answer should be compact. 0.81. What is the ratio of the Balance of Payment (as % of service exports) of Low & middle income in 2008 to that in 2009?
Make the answer very short. 1.15. What is the ratio of the Balance of Payment (as % of service exports) of Australia in 2008 to that in 2009?
Provide a succinct answer. 1.31. What is the ratio of the Balance of Payment (as % of service exports) of Guyana in 2008 to that in 2009?
Ensure brevity in your answer.  0.76. What is the ratio of the Balance of Payment (as % of service exports) in Romania in 2008 to that in 2009?
Offer a terse response. 0.99. What is the ratio of the Balance of Payment (as % of service exports) of Low & middle income in 2008 to that in 2010?
Ensure brevity in your answer.  1.09. What is the ratio of the Balance of Payment (as % of service exports) of Australia in 2008 to that in 2010?
Your answer should be compact. 1.32. What is the ratio of the Balance of Payment (as % of service exports) of Guyana in 2008 to that in 2010?
Your response must be concise. 0.8. What is the ratio of the Balance of Payment (as % of service exports) of Low & middle income in 2008 to that in 2011?
Your answer should be very brief. 1.08. What is the ratio of the Balance of Payment (as % of service exports) in Australia in 2008 to that in 2011?
Your response must be concise. 1.34. What is the ratio of the Balance of Payment (as % of service exports) of Guyana in 2008 to that in 2011?
Ensure brevity in your answer.  0.69. What is the ratio of the Balance of Payment (as % of service exports) in Romania in 2008 to that in 2011?
Your answer should be very brief. 0.98. What is the ratio of the Balance of Payment (as % of service exports) of Low & middle income in 2009 to that in 2010?
Make the answer very short. 0.95. What is the ratio of the Balance of Payment (as % of service exports) in Guyana in 2009 to that in 2010?
Offer a very short reply. 1.05. What is the ratio of the Balance of Payment (as % of service exports) of Romania in 2009 to that in 2010?
Your answer should be very brief. 1.04. What is the ratio of the Balance of Payment (as % of service exports) of Low & middle income in 2009 to that in 2011?
Provide a succinct answer. 0.94. What is the ratio of the Balance of Payment (as % of service exports) of Australia in 2009 to that in 2011?
Make the answer very short. 1.02. What is the ratio of the Balance of Payment (as % of service exports) in Guyana in 2009 to that in 2011?
Make the answer very short. 0.91. What is the ratio of the Balance of Payment (as % of service exports) in Romania in 2009 to that in 2011?
Your answer should be very brief. 0.99. What is the ratio of the Balance of Payment (as % of service exports) in Low & middle income in 2010 to that in 2011?
Your answer should be very brief. 0.99. What is the ratio of the Balance of Payment (as % of service exports) in Australia in 2010 to that in 2011?
Offer a terse response. 1.02. What is the ratio of the Balance of Payment (as % of service exports) in Guyana in 2010 to that in 2011?
Provide a succinct answer. 0.86. What is the ratio of the Balance of Payment (as % of service exports) in Romania in 2010 to that in 2011?
Provide a short and direct response. 0.96. What is the difference between the highest and the second highest Balance of Payment (as % of service exports) in Low & middle income?
Make the answer very short. 0.79. What is the difference between the highest and the second highest Balance of Payment (as % of service exports) in Australia?
Ensure brevity in your answer.  0.83. What is the difference between the highest and the second highest Balance of Payment (as % of service exports) of Guyana?
Provide a short and direct response. 0.59. What is the difference between the highest and the second highest Balance of Payment (as % of service exports) of Romania?
Keep it short and to the point. 0.17. What is the difference between the highest and the lowest Balance of Payment (as % of service exports) in Low & middle income?
Keep it short and to the point. 2.69. What is the difference between the highest and the lowest Balance of Payment (as % of service exports) in Australia?
Keep it short and to the point. 5.92. What is the difference between the highest and the lowest Balance of Payment (as % of service exports) of Guyana?
Your answer should be compact. 1.99. What is the difference between the highest and the lowest Balance of Payment (as % of service exports) in Romania?
Provide a short and direct response. 8.81. 